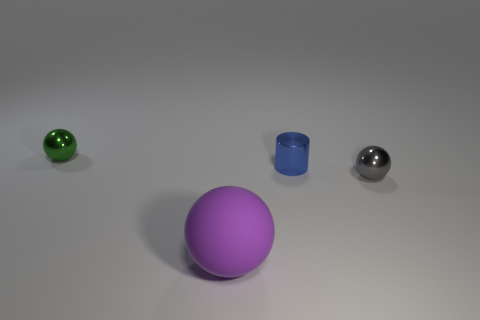Subtract all small shiny balls. How many balls are left? 1 Subtract all gray balls. How many balls are left? 2 Subtract all cylinders. How many objects are left? 3 Add 2 tiny green metallic balls. How many objects exist? 6 Subtract 0 brown spheres. How many objects are left? 4 Subtract all cyan balls. Subtract all brown cubes. How many balls are left? 3 Subtract all red blocks. How many gray balls are left? 1 Subtract all big matte balls. Subtract all cyan shiny things. How many objects are left? 3 Add 1 gray balls. How many gray balls are left? 2 Add 2 small things. How many small things exist? 5 